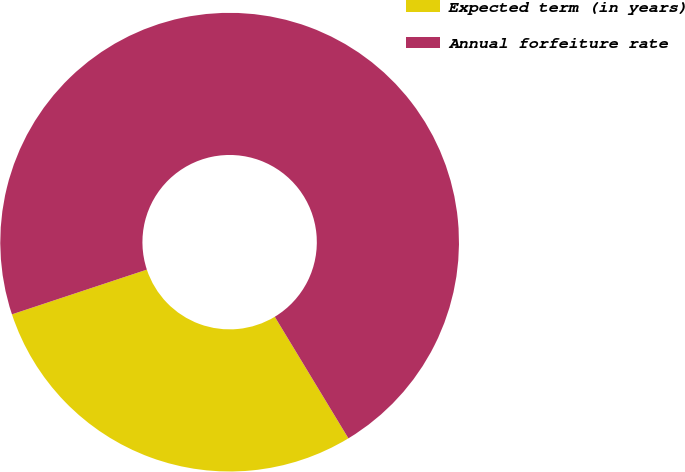<chart> <loc_0><loc_0><loc_500><loc_500><pie_chart><fcel>Expected term (in years)<fcel>Annual forfeiture rate<nl><fcel>28.57%<fcel>71.43%<nl></chart> 